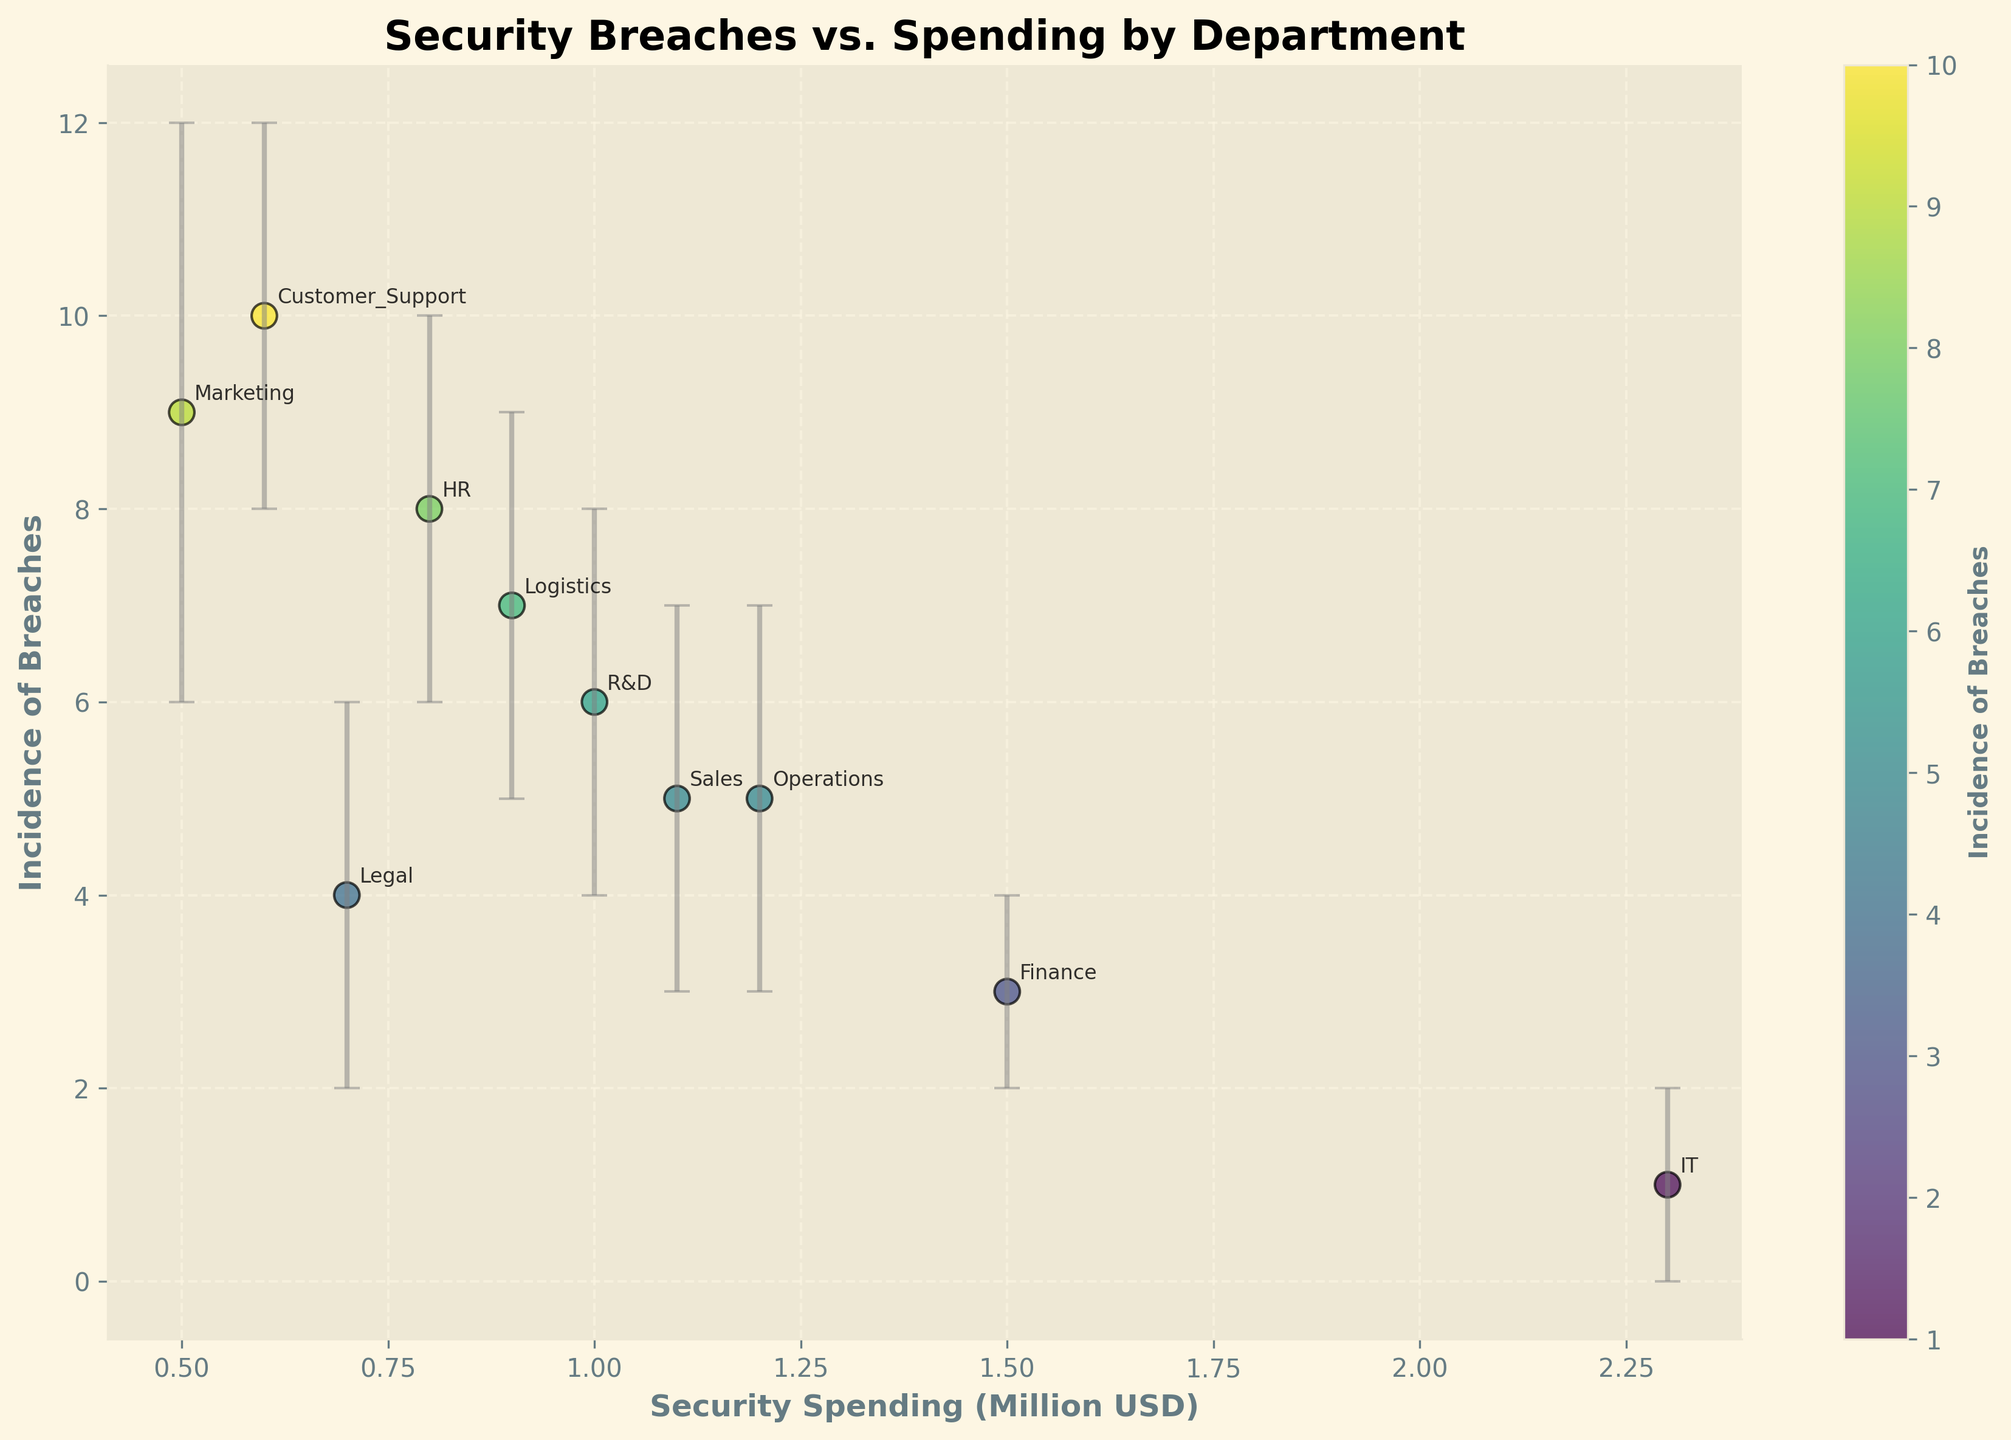How many departments are plotted in the figure? To find the number of departments, we count the distinct labeled points on the scatter plot. Each point represents a different department.
Answer: 10 What is the title of the plot? The title of the plot is located at the top center and describes the entire image.
Answer: Security Breaches vs. Spending by Department Which department has the highest incidence of breaches? By looking at the y-axis, representing the incidence of breaches, and identifying the highest point, we see that the department labeled at this point represents the highest incidence.
Answer: Customer Support What is the range of security spending displayed on the x-axis? The x-axis represents security spending in million USD. We look at the minimum and maximum ticks on the x-axis to determine the range.
Answer: 0.5 to 2.3 million USD Which department had the lowest incidence of breaches, and what was the reported number? By examining the y-axis for the lowest incidence value and identifying the corresponding department label, we find the department with the lowest breaches.
Answer: IT, 1 What is the incidence of breaches for departments that spend more than 1 million USD on security? From the scatter plot, we identify points where the x-axis value (security spending) is greater than 1 (million USD) and list the corresponding y-values (incidence of breaches) for those points.
Answer: Finance: 3, IT: 1, Operations: 5, Sales: 5 How many departments have their lower confidence intervals overlapping with an incidence of 4 breaches? Locate the error bars that dip down to or below the incidence line at 4 breaches on the y-axis. Count the number of departments with such error bars.
Answer: 2 Which department shows the largest error bar in terms of incidence of breaches, and what is its range? Identify the department with the longest vertical error bar by visually inspecting the height of the error bars and checking the range mentioned.
Answer: Marketing, 6 to 12 How does the incidence of breaches in the HR department compare with that of the operations department? Locate the HR and Operations points on the plot and compare their y-values. HR has a value of 8, and Operations has a value of 5.
Answer: HR > Operations What is the incidence range for the department with the highest security spending? Determine which department has the highest spending on the x-axis, identify its position, and then check the error bar range on the y-axis.
Answer: IT, 0 to 2 